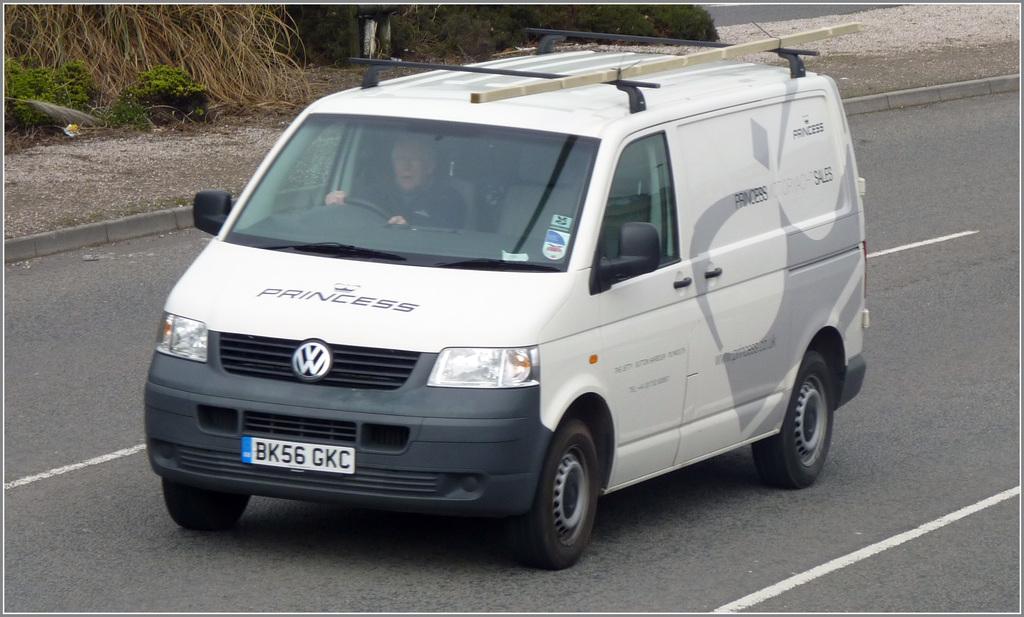What are the three letters on the license plate?
Your response must be concise. Gkc. What is the license plate number of this van?
Your answer should be very brief. Bk56 gkc. 